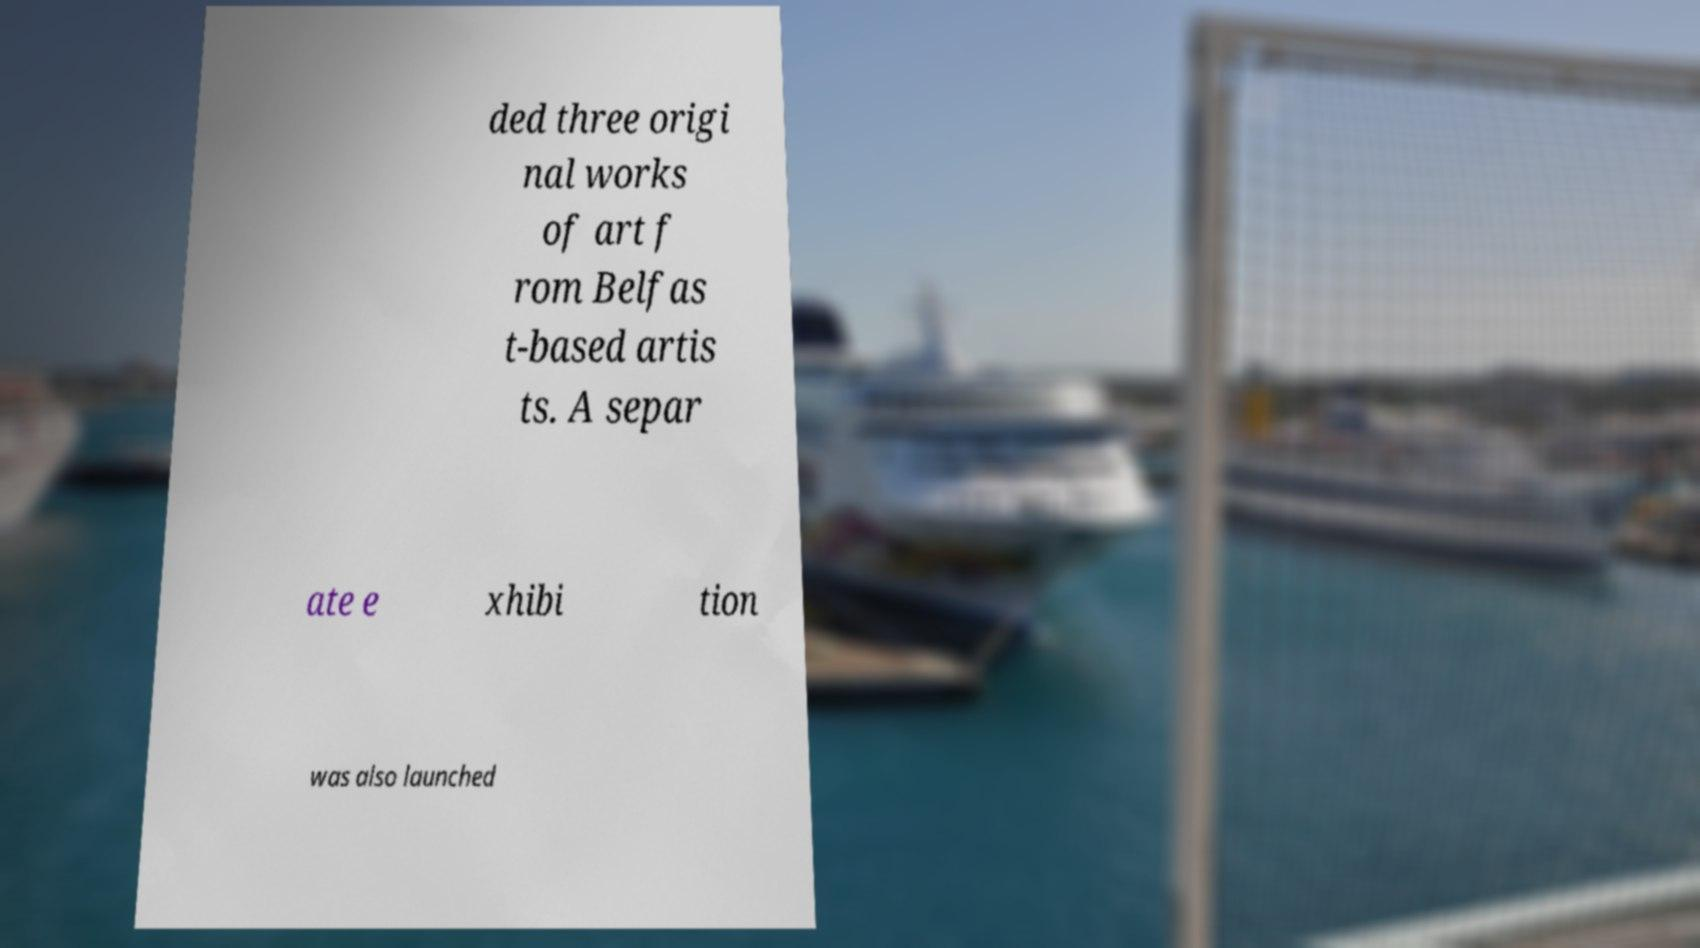Could you assist in decoding the text presented in this image and type it out clearly? ded three origi nal works of art f rom Belfas t-based artis ts. A separ ate e xhibi tion was also launched 